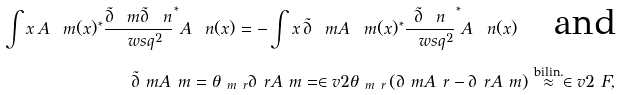<formula> <loc_0><loc_0><loc_500><loc_500>\int x \, A _ { \ } m ( x ) ^ { * } \frac { \tilde { \partial } _ { \ } m \tilde { \partial } _ { \ } n } { \ w s q ^ { 2 } } ^ { * } A _ { \ } n ( x ) = - \int x \, \tilde { \partial } _ { \ } m A _ { \ } m ( x ) ^ { * } \frac { \tilde { \partial } _ { \ } n } { \ w s q ^ { 2 } } ^ { * } A _ { \ } n ( x ) \quad \text {and} \\ \tilde { \partial } _ { \ } m A _ { \ } m = \theta _ { \ m \ r } \partial _ { \ } r A _ { \ } m = \in v { 2 } \theta _ { \ m \ r } \left ( \partial _ { \ } m A _ { \ } r - \partial _ { \ } r A _ { \ } m \right ) \overset { \text {bilin.} } { \approx } \in v { 2 } \ F ,</formula> 